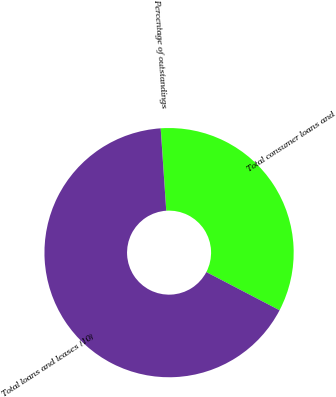<chart> <loc_0><loc_0><loc_500><loc_500><pie_chart><fcel>Total consumer loans and<fcel>Total loans and leases (10)<fcel>Percentage of outstandings<nl><fcel>33.71%<fcel>66.28%<fcel>0.01%<nl></chart> 